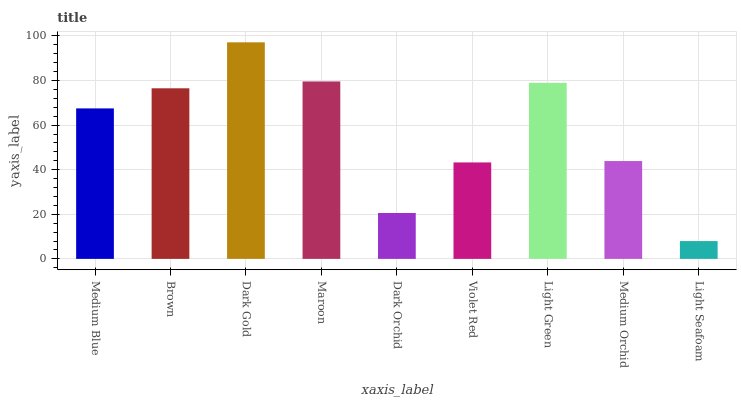Is Light Seafoam the minimum?
Answer yes or no. Yes. Is Dark Gold the maximum?
Answer yes or no. Yes. Is Brown the minimum?
Answer yes or no. No. Is Brown the maximum?
Answer yes or no. No. Is Brown greater than Medium Blue?
Answer yes or no. Yes. Is Medium Blue less than Brown?
Answer yes or no. Yes. Is Medium Blue greater than Brown?
Answer yes or no. No. Is Brown less than Medium Blue?
Answer yes or no. No. Is Medium Blue the high median?
Answer yes or no. Yes. Is Medium Blue the low median?
Answer yes or no. Yes. Is Maroon the high median?
Answer yes or no. No. Is Brown the low median?
Answer yes or no. No. 